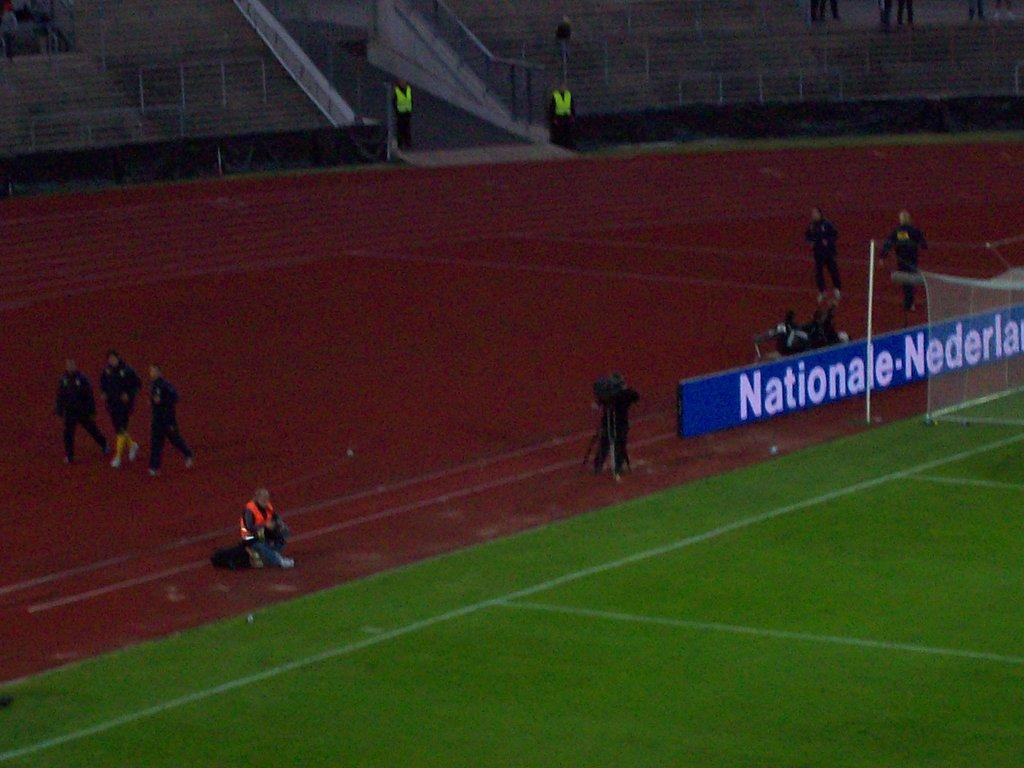<image>
Create a compact narrative representing the image presented. People are walking around a track while some sit behind the Nationale banner. 